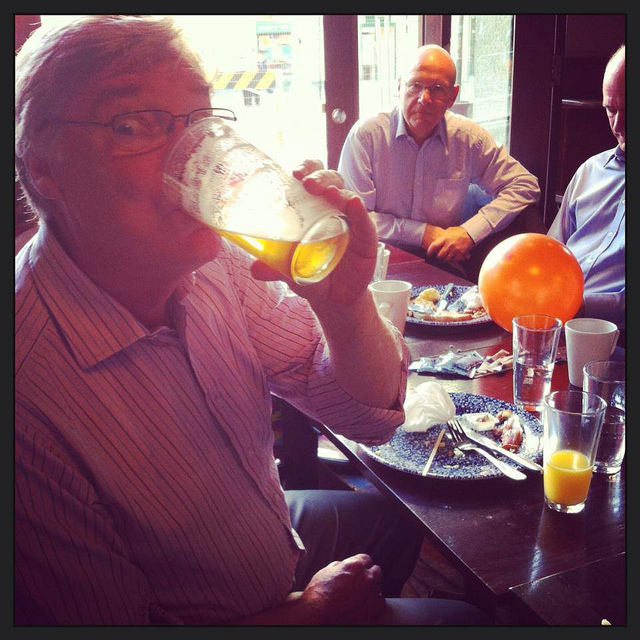<image>Have the men started eating? I am not sure if the men have started eating. Have the men started eating? I am not sure if the men have started eating. It can be seen both yes and not sure. 